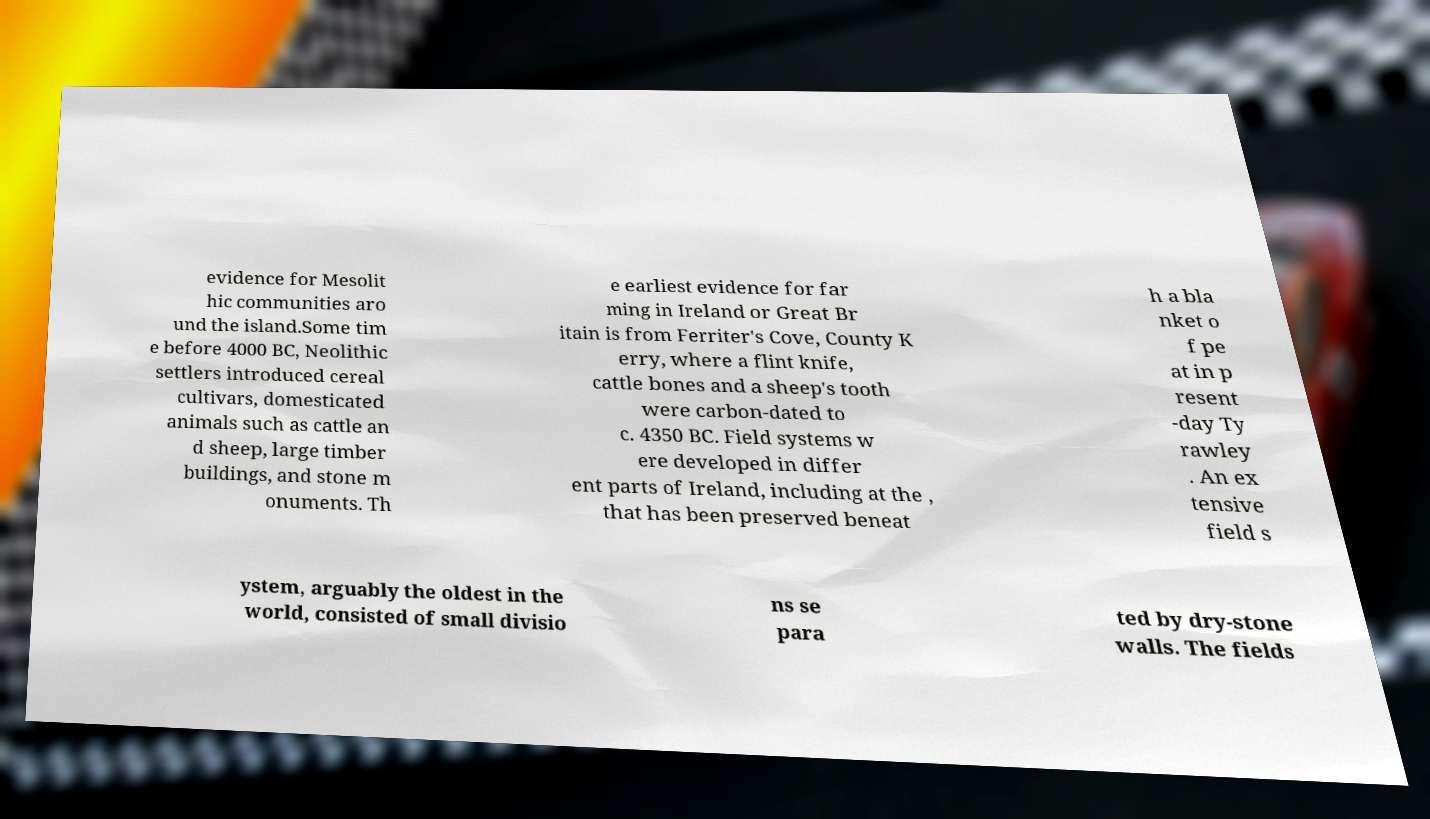What messages or text are displayed in this image? I need them in a readable, typed format. evidence for Mesolit hic communities aro und the island.Some tim e before 4000 BC, Neolithic settlers introduced cereal cultivars, domesticated animals such as cattle an d sheep, large timber buildings, and stone m onuments. Th e earliest evidence for far ming in Ireland or Great Br itain is from Ferriter's Cove, County K erry, where a flint knife, cattle bones and a sheep's tooth were carbon-dated to c. 4350 BC. Field systems w ere developed in differ ent parts of Ireland, including at the , that has been preserved beneat h a bla nket o f pe at in p resent -day Ty rawley . An ex tensive field s ystem, arguably the oldest in the world, consisted of small divisio ns se para ted by dry-stone walls. The fields 